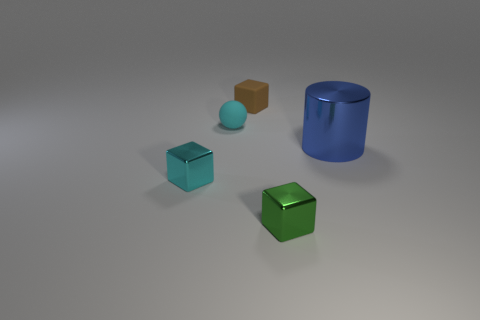Add 4 tiny rubber things. How many objects exist? 9 Subtract all cubes. How many objects are left? 2 Add 3 big cyan matte things. How many big cyan matte things exist? 3 Subtract 0 purple cubes. How many objects are left? 5 Subtract all cyan matte balls. Subtract all blue shiny cylinders. How many objects are left? 3 Add 3 small cyan matte balls. How many small cyan matte balls are left? 4 